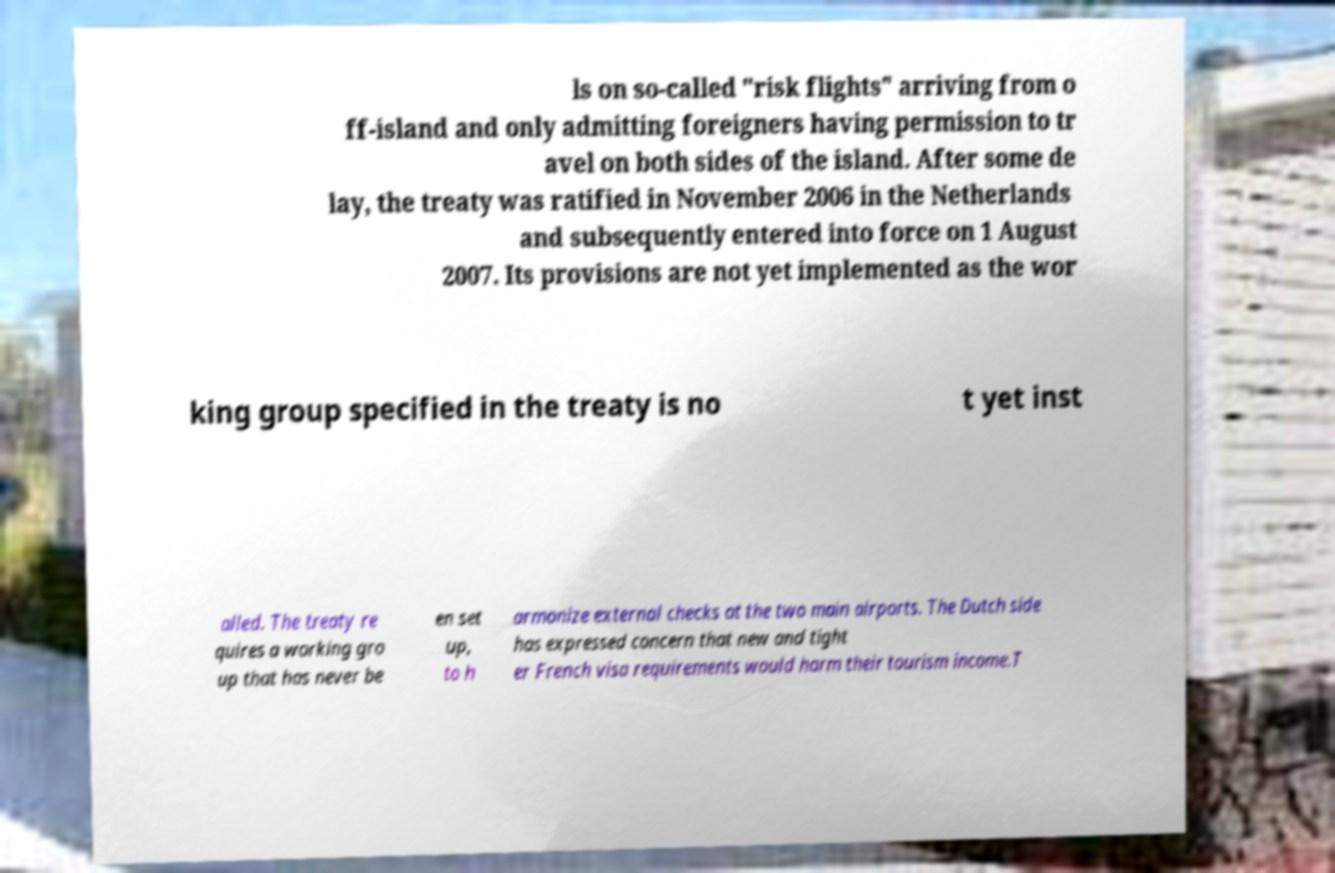Can you accurately transcribe the text from the provided image for me? ls on so-called "risk flights" arriving from o ff-island and only admitting foreigners having permission to tr avel on both sides of the island. After some de lay, the treaty was ratified in November 2006 in the Netherlands and subsequently entered into force on 1 August 2007. Its provisions are not yet implemented as the wor king group specified in the treaty is no t yet inst alled. The treaty re quires a working gro up that has never be en set up, to h armonize external checks at the two main airports. The Dutch side has expressed concern that new and tight er French visa requirements would harm their tourism income.T 